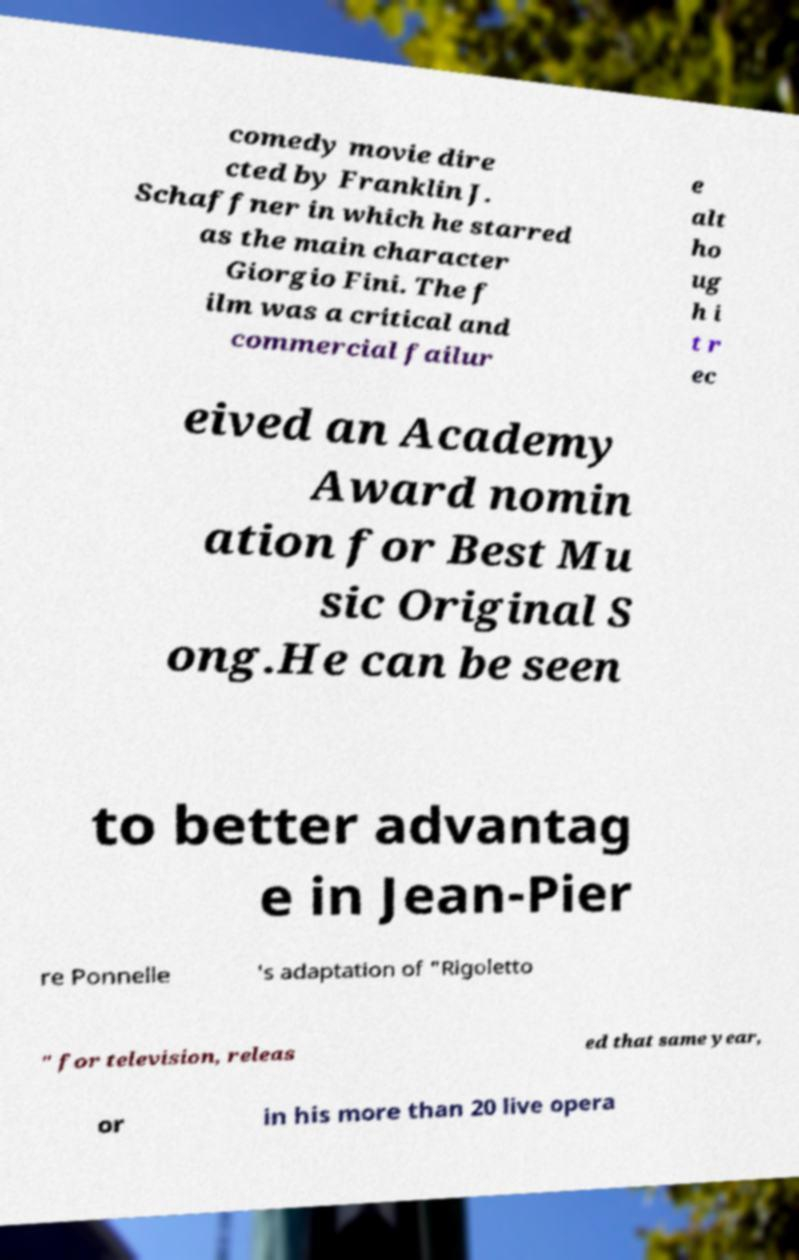Could you extract and type out the text from this image? comedy movie dire cted by Franklin J. Schaffner in which he starred as the main character Giorgio Fini. The f ilm was a critical and commercial failur e alt ho ug h i t r ec eived an Academy Award nomin ation for Best Mu sic Original S ong.He can be seen to better advantag e in Jean-Pier re Ponnelle 's adaptation of "Rigoletto " for television, releas ed that same year, or in his more than 20 live opera 